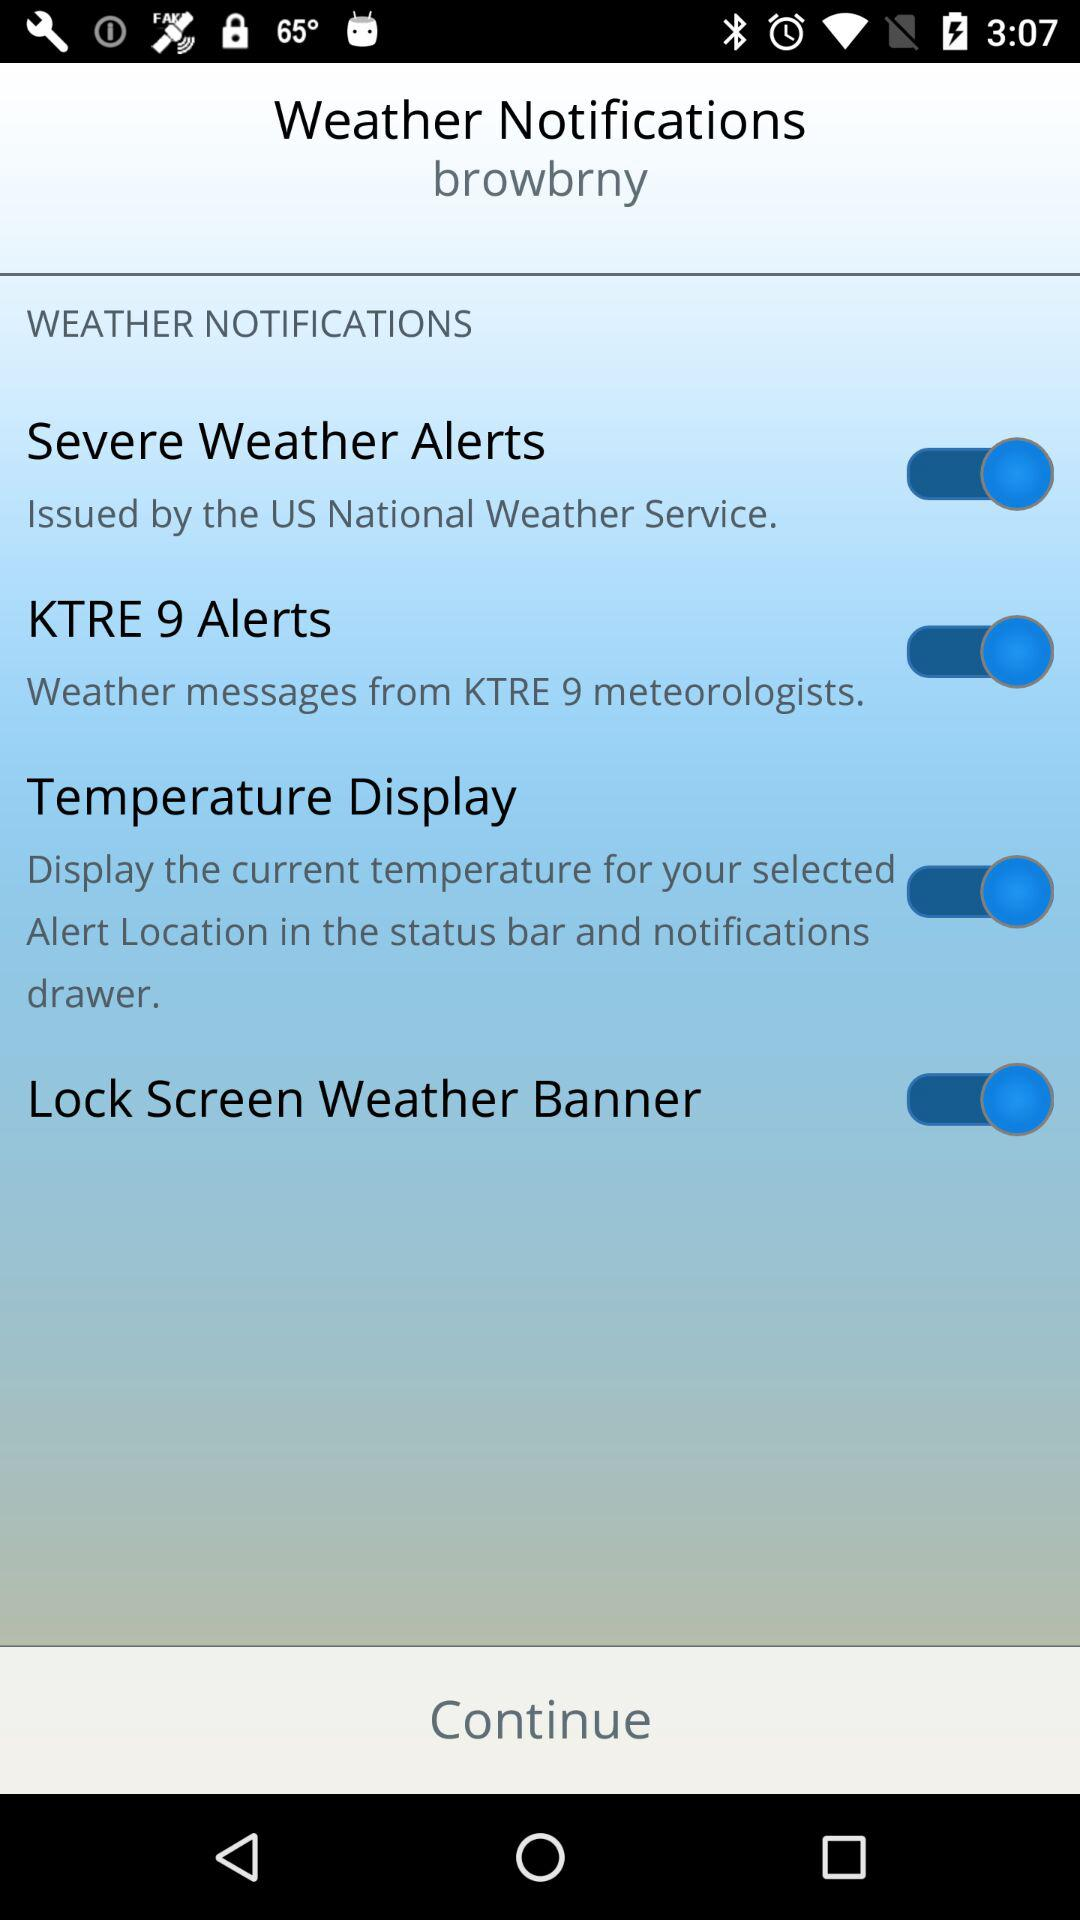Which location is selected for the weather notifications?
When the provided information is insufficient, respond with <no answer>. <no answer> 